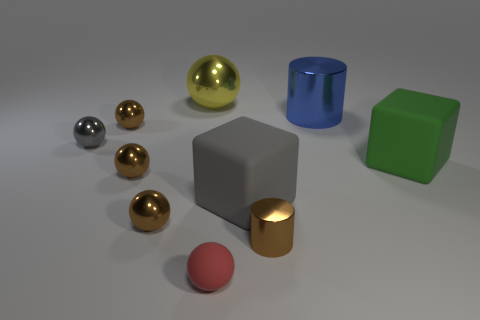Subtract all purple cylinders. How many brown spheres are left? 3 Subtract 3 spheres. How many spheres are left? 3 Subtract all red balls. How many balls are left? 5 Subtract all large metal balls. How many balls are left? 5 Subtract all purple balls. Subtract all purple cylinders. How many balls are left? 6 Subtract all blocks. How many objects are left? 8 Subtract 0 yellow cylinders. How many objects are left? 10 Subtract all gray cubes. Subtract all tiny brown objects. How many objects are left? 5 Add 3 big blue shiny cylinders. How many big blue shiny cylinders are left? 4 Add 6 small brown metal objects. How many small brown metal objects exist? 10 